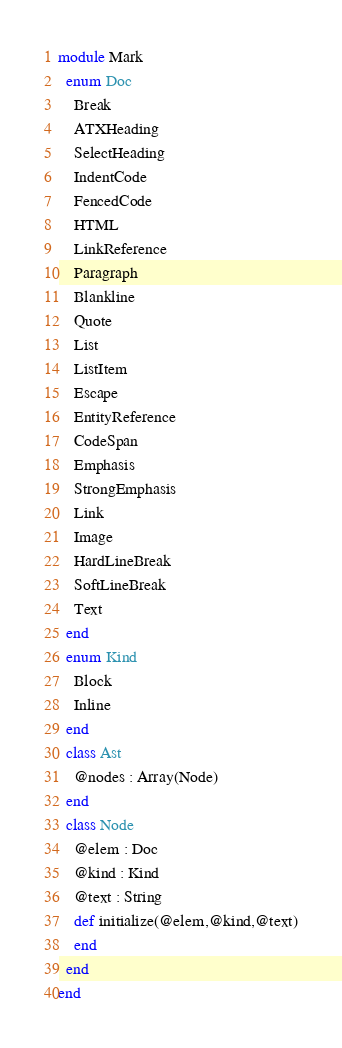<code> <loc_0><loc_0><loc_500><loc_500><_Crystal_>module Mark
  enum Doc
    Break
    ATXHeading
    SelectHeading
    IndentCode
    FencedCode
    HTML
    LinkReference
    Paragraph
    Blankline
    Quote
    List
    ListItem
    Escape
    EntityReference
    CodeSpan
    Emphasis
    StrongEmphasis
    Link
    Image
    HardLineBreak
    SoftLineBreak
    Text
  end
  enum Kind 
    Block
    Inline
  end
  class Ast
    @nodes : Array(Node)
  end
  class Node
    @elem : Doc
    @kind : Kind
    @text : String
    def initialize(@elem,@kind,@text)
    end
  end
end
</code> 